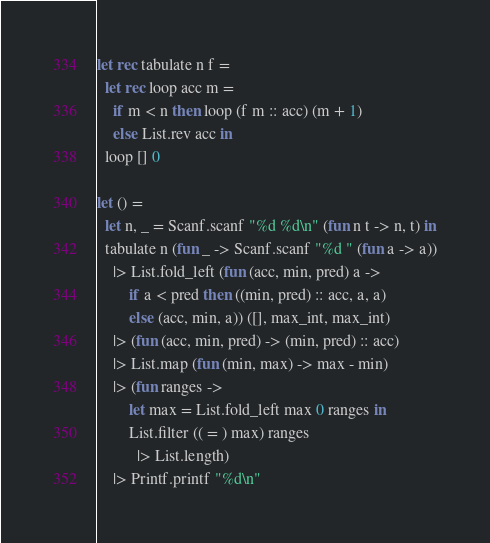<code> <loc_0><loc_0><loc_500><loc_500><_OCaml_>let rec tabulate n f = 
  let rec loop acc m =
    if m < n then loop (f m :: acc) (m + 1)
    else List.rev acc in
  loop [] 0

let () =
  let n, _ = Scanf.scanf "%d %d\n" (fun n t -> n, t) in
  tabulate n (fun _ -> Scanf.scanf "%d " (fun a -> a))
    |> List.fold_left (fun (acc, min, pred) a ->
        if a < pred then ((min, pred) :: acc, a, a)
        else (acc, min, a)) ([], max_int, max_int)
    |> (fun (acc, min, pred) -> (min, pred) :: acc)
    |> List.map (fun (min, max) -> max - min)
    |> (fun ranges ->
        let max = List.fold_left max 0 ranges in
        List.filter (( = ) max) ranges
          |> List.length)
    |> Printf.printf "%d\n"
</code> 